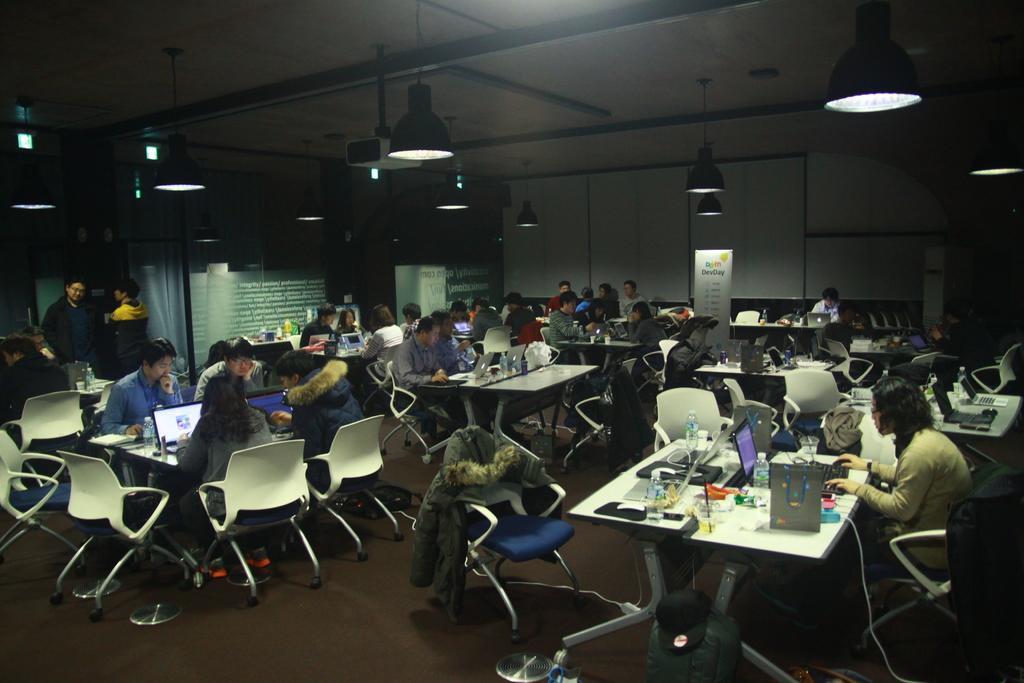Describe this image in one or two sentences. Most of the persons are sitting on chair. In-front of this person there is a table, on a table there are laptops, bag and bottles. Far there is a white banner. On top there are lights. This 2 persons are standing. On this chair there is a jacket. 